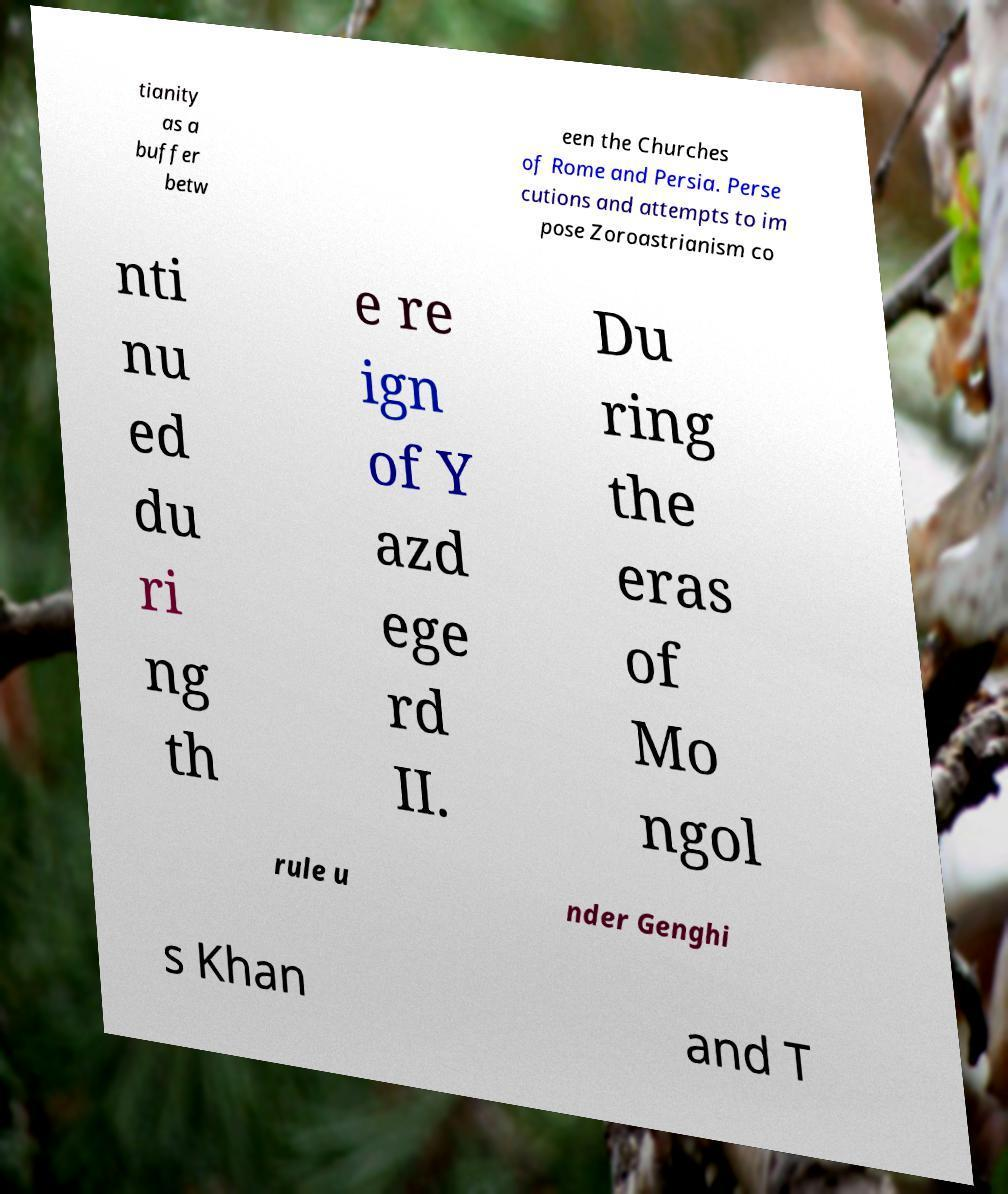What messages or text are displayed in this image? I need them in a readable, typed format. tianity as a buffer betw een the Churches of Rome and Persia. Perse cutions and attempts to im pose Zoroastrianism co nti nu ed du ri ng th e re ign of Y azd ege rd II. Du ring the eras of Mo ngol rule u nder Genghi s Khan and T 